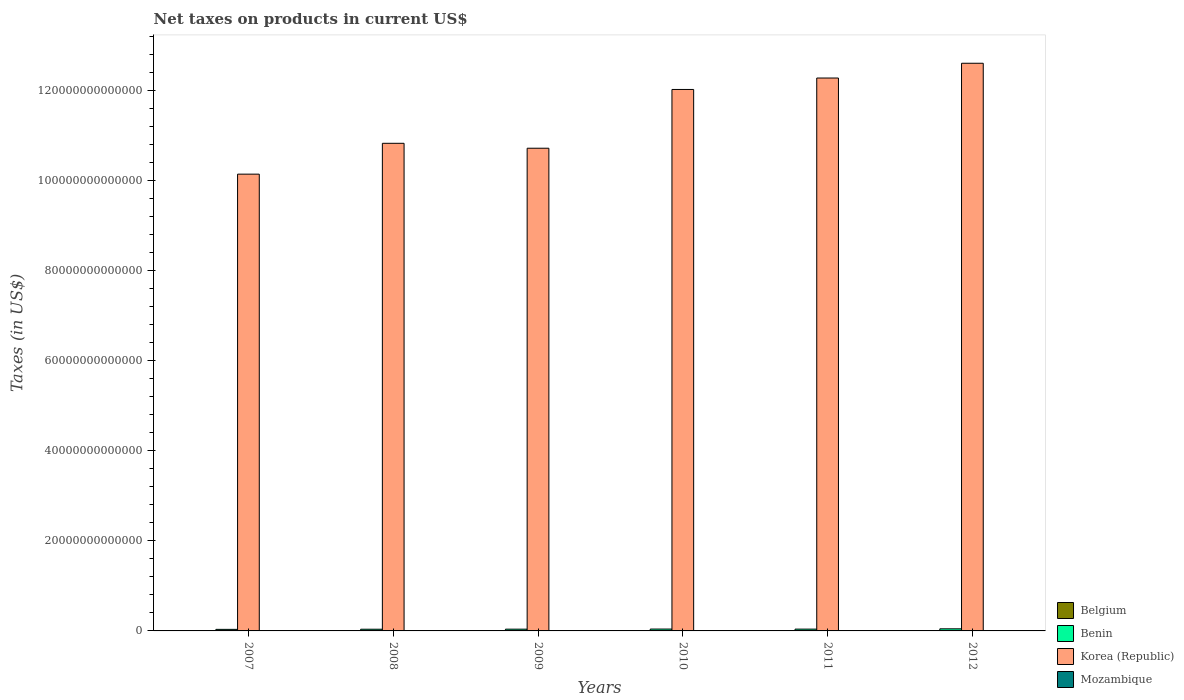How many different coloured bars are there?
Your answer should be very brief. 4. How many bars are there on the 3rd tick from the right?
Your response must be concise. 4. What is the label of the 4th group of bars from the left?
Your answer should be compact. 2010. What is the net taxes on products in Benin in 2012?
Keep it short and to the point. 4.67e+11. Across all years, what is the maximum net taxes on products in Mozambique?
Provide a short and direct response. 3.79e+1. Across all years, what is the minimum net taxes on products in Korea (Republic)?
Make the answer very short. 1.01e+14. In which year was the net taxes on products in Belgium maximum?
Offer a very short reply. 2012. What is the total net taxes on products in Benin in the graph?
Your answer should be compact. 2.40e+12. What is the difference between the net taxes on products in Belgium in 2011 and that in 2012?
Your answer should be very brief. -1.31e+09. What is the difference between the net taxes on products in Benin in 2009 and the net taxes on products in Mozambique in 2012?
Provide a succinct answer. 3.52e+11. What is the average net taxes on products in Korea (Republic) per year?
Make the answer very short. 1.14e+14. In the year 2009, what is the difference between the net taxes on products in Korea (Republic) and net taxes on products in Belgium?
Give a very brief answer. 1.07e+14. What is the ratio of the net taxes on products in Korea (Republic) in 2010 to that in 2011?
Offer a very short reply. 0.98. Is the net taxes on products in Belgium in 2009 less than that in 2011?
Keep it short and to the point. Yes. What is the difference between the highest and the second highest net taxes on products in Belgium?
Make the answer very short. 1.31e+09. What is the difference between the highest and the lowest net taxes on products in Mozambique?
Give a very brief answer. 1.96e+1. In how many years, is the net taxes on products in Mozambique greater than the average net taxes on products in Mozambique taken over all years?
Offer a very short reply. 2. What does the 1st bar from the left in 2007 represents?
Provide a short and direct response. Belgium. Is it the case that in every year, the sum of the net taxes on products in Benin and net taxes on products in Belgium is greater than the net taxes on products in Mozambique?
Provide a succinct answer. Yes. Are all the bars in the graph horizontal?
Give a very brief answer. No. What is the difference between two consecutive major ticks on the Y-axis?
Give a very brief answer. 2.00e+13. Does the graph contain any zero values?
Ensure brevity in your answer.  No. Does the graph contain grids?
Your response must be concise. No. Where does the legend appear in the graph?
Keep it short and to the point. Bottom right. How many legend labels are there?
Provide a succinct answer. 4. What is the title of the graph?
Keep it short and to the point. Net taxes on products in current US$. Does "Bangladesh" appear as one of the legend labels in the graph?
Your answer should be compact. No. What is the label or title of the Y-axis?
Your answer should be very brief. Taxes (in US$). What is the Taxes (in US$) of Belgium in 2007?
Offer a very short reply. 3.68e+1. What is the Taxes (in US$) in Benin in 2007?
Keep it short and to the point. 3.46e+11. What is the Taxes (in US$) of Korea (Republic) in 2007?
Keep it short and to the point. 1.01e+14. What is the Taxes (in US$) of Mozambique in 2007?
Your answer should be compact. 1.82e+1. What is the Taxes (in US$) in Belgium in 2008?
Give a very brief answer. 3.71e+1. What is the Taxes (in US$) in Benin in 2008?
Make the answer very short. 3.77e+11. What is the Taxes (in US$) in Korea (Republic) in 2008?
Give a very brief answer. 1.08e+14. What is the Taxes (in US$) of Mozambique in 2008?
Ensure brevity in your answer.  2.13e+1. What is the Taxes (in US$) in Belgium in 2009?
Offer a very short reply. 3.62e+1. What is the Taxes (in US$) of Benin in 2009?
Provide a succinct answer. 3.90e+11. What is the Taxes (in US$) of Korea (Republic) in 2009?
Offer a terse response. 1.07e+14. What is the Taxes (in US$) of Mozambique in 2009?
Offer a very short reply. 2.17e+1. What is the Taxes (in US$) in Belgium in 2010?
Offer a very short reply. 3.86e+1. What is the Taxes (in US$) in Benin in 2010?
Make the answer very short. 4.14e+11. What is the Taxes (in US$) of Korea (Republic) in 2010?
Your answer should be compact. 1.20e+14. What is the Taxes (in US$) in Mozambique in 2010?
Provide a succinct answer. 2.55e+1. What is the Taxes (in US$) of Belgium in 2011?
Make the answer very short. 3.95e+1. What is the Taxes (in US$) of Benin in 2011?
Keep it short and to the point. 4.02e+11. What is the Taxes (in US$) in Korea (Republic) in 2011?
Make the answer very short. 1.23e+14. What is the Taxes (in US$) in Mozambique in 2011?
Provide a succinct answer. 3.03e+1. What is the Taxes (in US$) in Belgium in 2012?
Your response must be concise. 4.08e+1. What is the Taxes (in US$) in Benin in 2012?
Provide a short and direct response. 4.67e+11. What is the Taxes (in US$) of Korea (Republic) in 2012?
Offer a very short reply. 1.26e+14. What is the Taxes (in US$) of Mozambique in 2012?
Provide a succinct answer. 3.79e+1. Across all years, what is the maximum Taxes (in US$) of Belgium?
Offer a very short reply. 4.08e+1. Across all years, what is the maximum Taxes (in US$) of Benin?
Ensure brevity in your answer.  4.67e+11. Across all years, what is the maximum Taxes (in US$) in Korea (Republic)?
Keep it short and to the point. 1.26e+14. Across all years, what is the maximum Taxes (in US$) in Mozambique?
Provide a short and direct response. 3.79e+1. Across all years, what is the minimum Taxes (in US$) in Belgium?
Give a very brief answer. 3.62e+1. Across all years, what is the minimum Taxes (in US$) of Benin?
Ensure brevity in your answer.  3.46e+11. Across all years, what is the minimum Taxes (in US$) of Korea (Republic)?
Offer a very short reply. 1.01e+14. Across all years, what is the minimum Taxes (in US$) in Mozambique?
Keep it short and to the point. 1.82e+1. What is the total Taxes (in US$) in Belgium in the graph?
Ensure brevity in your answer.  2.29e+11. What is the total Taxes (in US$) of Benin in the graph?
Offer a very short reply. 2.40e+12. What is the total Taxes (in US$) of Korea (Republic) in the graph?
Your answer should be very brief. 6.86e+14. What is the total Taxes (in US$) of Mozambique in the graph?
Provide a short and direct response. 1.55e+11. What is the difference between the Taxes (in US$) in Belgium in 2007 and that in 2008?
Offer a very short reply. -3.04e+08. What is the difference between the Taxes (in US$) in Benin in 2007 and that in 2008?
Keep it short and to the point. -3.13e+1. What is the difference between the Taxes (in US$) of Korea (Republic) in 2007 and that in 2008?
Offer a very short reply. -6.85e+12. What is the difference between the Taxes (in US$) in Mozambique in 2007 and that in 2008?
Provide a succinct answer. -3.04e+09. What is the difference between the Taxes (in US$) of Belgium in 2007 and that in 2009?
Your response must be concise. 5.68e+08. What is the difference between the Taxes (in US$) in Benin in 2007 and that in 2009?
Your answer should be very brief. -4.38e+1. What is the difference between the Taxes (in US$) of Korea (Republic) in 2007 and that in 2009?
Your answer should be very brief. -5.76e+12. What is the difference between the Taxes (in US$) in Mozambique in 2007 and that in 2009?
Offer a very short reply. -3.43e+09. What is the difference between the Taxes (in US$) of Belgium in 2007 and that in 2010?
Offer a very short reply. -1.81e+09. What is the difference between the Taxes (in US$) in Benin in 2007 and that in 2010?
Offer a very short reply. -6.76e+1. What is the difference between the Taxes (in US$) of Korea (Republic) in 2007 and that in 2010?
Ensure brevity in your answer.  -1.88e+13. What is the difference between the Taxes (in US$) in Mozambique in 2007 and that in 2010?
Your response must be concise. -7.21e+09. What is the difference between the Taxes (in US$) in Belgium in 2007 and that in 2011?
Offer a very short reply. -2.71e+09. What is the difference between the Taxes (in US$) of Benin in 2007 and that in 2011?
Offer a very short reply. -5.54e+1. What is the difference between the Taxes (in US$) in Korea (Republic) in 2007 and that in 2011?
Your response must be concise. -2.13e+13. What is the difference between the Taxes (in US$) in Mozambique in 2007 and that in 2011?
Ensure brevity in your answer.  -1.20e+1. What is the difference between the Taxes (in US$) of Belgium in 2007 and that in 2012?
Provide a succinct answer. -4.02e+09. What is the difference between the Taxes (in US$) of Benin in 2007 and that in 2012?
Make the answer very short. -1.21e+11. What is the difference between the Taxes (in US$) of Korea (Republic) in 2007 and that in 2012?
Keep it short and to the point. -2.46e+13. What is the difference between the Taxes (in US$) of Mozambique in 2007 and that in 2012?
Your response must be concise. -1.96e+1. What is the difference between the Taxes (in US$) in Belgium in 2008 and that in 2009?
Provide a short and direct response. 8.72e+08. What is the difference between the Taxes (in US$) in Benin in 2008 and that in 2009?
Provide a short and direct response. -1.25e+1. What is the difference between the Taxes (in US$) in Korea (Republic) in 2008 and that in 2009?
Your response must be concise. 1.09e+12. What is the difference between the Taxes (in US$) in Mozambique in 2008 and that in 2009?
Your answer should be compact. -3.89e+08. What is the difference between the Taxes (in US$) of Belgium in 2008 and that in 2010?
Offer a very short reply. -1.51e+09. What is the difference between the Taxes (in US$) in Benin in 2008 and that in 2010?
Make the answer very short. -3.63e+1. What is the difference between the Taxes (in US$) of Korea (Republic) in 2008 and that in 2010?
Give a very brief answer. -1.19e+13. What is the difference between the Taxes (in US$) in Mozambique in 2008 and that in 2010?
Provide a short and direct response. -4.17e+09. What is the difference between the Taxes (in US$) in Belgium in 2008 and that in 2011?
Your answer should be very brief. -2.40e+09. What is the difference between the Taxes (in US$) of Benin in 2008 and that in 2011?
Provide a short and direct response. -2.41e+1. What is the difference between the Taxes (in US$) of Korea (Republic) in 2008 and that in 2011?
Make the answer very short. -1.45e+13. What is the difference between the Taxes (in US$) in Mozambique in 2008 and that in 2011?
Ensure brevity in your answer.  -8.98e+09. What is the difference between the Taxes (in US$) in Belgium in 2008 and that in 2012?
Provide a succinct answer. -3.72e+09. What is the difference between the Taxes (in US$) in Benin in 2008 and that in 2012?
Provide a short and direct response. -8.93e+1. What is the difference between the Taxes (in US$) of Korea (Republic) in 2008 and that in 2012?
Offer a very short reply. -1.78e+13. What is the difference between the Taxes (in US$) in Mozambique in 2008 and that in 2012?
Your answer should be compact. -1.66e+1. What is the difference between the Taxes (in US$) in Belgium in 2009 and that in 2010?
Provide a short and direct response. -2.38e+09. What is the difference between the Taxes (in US$) in Benin in 2009 and that in 2010?
Offer a very short reply. -2.38e+1. What is the difference between the Taxes (in US$) of Korea (Republic) in 2009 and that in 2010?
Offer a very short reply. -1.30e+13. What is the difference between the Taxes (in US$) in Mozambique in 2009 and that in 2010?
Give a very brief answer. -3.78e+09. What is the difference between the Taxes (in US$) of Belgium in 2009 and that in 2011?
Your answer should be very brief. -3.28e+09. What is the difference between the Taxes (in US$) of Benin in 2009 and that in 2011?
Your answer should be very brief. -1.16e+1. What is the difference between the Taxes (in US$) in Korea (Republic) in 2009 and that in 2011?
Keep it short and to the point. -1.56e+13. What is the difference between the Taxes (in US$) in Mozambique in 2009 and that in 2011?
Provide a short and direct response. -8.59e+09. What is the difference between the Taxes (in US$) of Belgium in 2009 and that in 2012?
Provide a succinct answer. -4.59e+09. What is the difference between the Taxes (in US$) in Benin in 2009 and that in 2012?
Offer a very short reply. -7.68e+1. What is the difference between the Taxes (in US$) of Korea (Republic) in 2009 and that in 2012?
Your answer should be very brief. -1.89e+13. What is the difference between the Taxes (in US$) of Mozambique in 2009 and that in 2012?
Offer a terse response. -1.62e+1. What is the difference between the Taxes (in US$) in Belgium in 2010 and that in 2011?
Offer a very short reply. -8.95e+08. What is the difference between the Taxes (in US$) of Benin in 2010 and that in 2011?
Your response must be concise. 1.22e+1. What is the difference between the Taxes (in US$) of Korea (Republic) in 2010 and that in 2011?
Provide a succinct answer. -2.54e+12. What is the difference between the Taxes (in US$) in Mozambique in 2010 and that in 2011?
Provide a succinct answer. -4.81e+09. What is the difference between the Taxes (in US$) of Belgium in 2010 and that in 2012?
Ensure brevity in your answer.  -2.21e+09. What is the difference between the Taxes (in US$) of Benin in 2010 and that in 2012?
Keep it short and to the point. -5.30e+1. What is the difference between the Taxes (in US$) in Korea (Republic) in 2010 and that in 2012?
Give a very brief answer. -5.82e+12. What is the difference between the Taxes (in US$) of Mozambique in 2010 and that in 2012?
Offer a terse response. -1.24e+1. What is the difference between the Taxes (in US$) in Belgium in 2011 and that in 2012?
Ensure brevity in your answer.  -1.31e+09. What is the difference between the Taxes (in US$) of Benin in 2011 and that in 2012?
Your answer should be very brief. -6.52e+1. What is the difference between the Taxes (in US$) in Korea (Republic) in 2011 and that in 2012?
Make the answer very short. -3.28e+12. What is the difference between the Taxes (in US$) in Mozambique in 2011 and that in 2012?
Offer a very short reply. -7.59e+09. What is the difference between the Taxes (in US$) of Belgium in 2007 and the Taxes (in US$) of Benin in 2008?
Your answer should be compact. -3.41e+11. What is the difference between the Taxes (in US$) of Belgium in 2007 and the Taxes (in US$) of Korea (Republic) in 2008?
Your answer should be very brief. -1.08e+14. What is the difference between the Taxes (in US$) of Belgium in 2007 and the Taxes (in US$) of Mozambique in 2008?
Your answer should be very brief. 1.55e+1. What is the difference between the Taxes (in US$) of Benin in 2007 and the Taxes (in US$) of Korea (Republic) in 2008?
Your answer should be compact. -1.08e+14. What is the difference between the Taxes (in US$) of Benin in 2007 and the Taxes (in US$) of Mozambique in 2008?
Make the answer very short. 3.25e+11. What is the difference between the Taxes (in US$) in Korea (Republic) in 2007 and the Taxes (in US$) in Mozambique in 2008?
Make the answer very short. 1.01e+14. What is the difference between the Taxes (in US$) in Belgium in 2007 and the Taxes (in US$) in Benin in 2009?
Make the answer very short. -3.53e+11. What is the difference between the Taxes (in US$) in Belgium in 2007 and the Taxes (in US$) in Korea (Republic) in 2009?
Offer a very short reply. -1.07e+14. What is the difference between the Taxes (in US$) in Belgium in 2007 and the Taxes (in US$) in Mozambique in 2009?
Keep it short and to the point. 1.51e+1. What is the difference between the Taxes (in US$) in Benin in 2007 and the Taxes (in US$) in Korea (Republic) in 2009?
Offer a terse response. -1.07e+14. What is the difference between the Taxes (in US$) in Benin in 2007 and the Taxes (in US$) in Mozambique in 2009?
Make the answer very short. 3.24e+11. What is the difference between the Taxes (in US$) of Korea (Republic) in 2007 and the Taxes (in US$) of Mozambique in 2009?
Give a very brief answer. 1.01e+14. What is the difference between the Taxes (in US$) in Belgium in 2007 and the Taxes (in US$) in Benin in 2010?
Give a very brief answer. -3.77e+11. What is the difference between the Taxes (in US$) in Belgium in 2007 and the Taxes (in US$) in Korea (Republic) in 2010?
Your response must be concise. -1.20e+14. What is the difference between the Taxes (in US$) in Belgium in 2007 and the Taxes (in US$) in Mozambique in 2010?
Offer a very short reply. 1.13e+1. What is the difference between the Taxes (in US$) in Benin in 2007 and the Taxes (in US$) in Korea (Republic) in 2010?
Your response must be concise. -1.20e+14. What is the difference between the Taxes (in US$) in Benin in 2007 and the Taxes (in US$) in Mozambique in 2010?
Provide a short and direct response. 3.21e+11. What is the difference between the Taxes (in US$) of Korea (Republic) in 2007 and the Taxes (in US$) of Mozambique in 2010?
Provide a succinct answer. 1.01e+14. What is the difference between the Taxes (in US$) of Belgium in 2007 and the Taxes (in US$) of Benin in 2011?
Offer a terse response. -3.65e+11. What is the difference between the Taxes (in US$) of Belgium in 2007 and the Taxes (in US$) of Korea (Republic) in 2011?
Offer a very short reply. -1.23e+14. What is the difference between the Taxes (in US$) of Belgium in 2007 and the Taxes (in US$) of Mozambique in 2011?
Your answer should be compact. 6.49e+09. What is the difference between the Taxes (in US$) of Benin in 2007 and the Taxes (in US$) of Korea (Republic) in 2011?
Make the answer very short. -1.22e+14. What is the difference between the Taxes (in US$) in Benin in 2007 and the Taxes (in US$) in Mozambique in 2011?
Ensure brevity in your answer.  3.16e+11. What is the difference between the Taxes (in US$) in Korea (Republic) in 2007 and the Taxes (in US$) in Mozambique in 2011?
Offer a terse response. 1.01e+14. What is the difference between the Taxes (in US$) of Belgium in 2007 and the Taxes (in US$) of Benin in 2012?
Make the answer very short. -4.30e+11. What is the difference between the Taxes (in US$) in Belgium in 2007 and the Taxes (in US$) in Korea (Republic) in 2012?
Offer a very short reply. -1.26e+14. What is the difference between the Taxes (in US$) of Belgium in 2007 and the Taxes (in US$) of Mozambique in 2012?
Ensure brevity in your answer.  -1.10e+09. What is the difference between the Taxes (in US$) of Benin in 2007 and the Taxes (in US$) of Korea (Republic) in 2012?
Your answer should be very brief. -1.26e+14. What is the difference between the Taxes (in US$) of Benin in 2007 and the Taxes (in US$) of Mozambique in 2012?
Offer a terse response. 3.08e+11. What is the difference between the Taxes (in US$) in Korea (Republic) in 2007 and the Taxes (in US$) in Mozambique in 2012?
Provide a short and direct response. 1.01e+14. What is the difference between the Taxes (in US$) of Belgium in 2008 and the Taxes (in US$) of Benin in 2009?
Keep it short and to the point. -3.53e+11. What is the difference between the Taxes (in US$) of Belgium in 2008 and the Taxes (in US$) of Korea (Republic) in 2009?
Your response must be concise. -1.07e+14. What is the difference between the Taxes (in US$) of Belgium in 2008 and the Taxes (in US$) of Mozambique in 2009?
Give a very brief answer. 1.54e+1. What is the difference between the Taxes (in US$) of Benin in 2008 and the Taxes (in US$) of Korea (Republic) in 2009?
Your answer should be compact. -1.07e+14. What is the difference between the Taxes (in US$) of Benin in 2008 and the Taxes (in US$) of Mozambique in 2009?
Your answer should be very brief. 3.56e+11. What is the difference between the Taxes (in US$) in Korea (Republic) in 2008 and the Taxes (in US$) in Mozambique in 2009?
Ensure brevity in your answer.  1.08e+14. What is the difference between the Taxes (in US$) in Belgium in 2008 and the Taxes (in US$) in Benin in 2010?
Provide a succinct answer. -3.77e+11. What is the difference between the Taxes (in US$) in Belgium in 2008 and the Taxes (in US$) in Korea (Republic) in 2010?
Provide a succinct answer. -1.20e+14. What is the difference between the Taxes (in US$) in Belgium in 2008 and the Taxes (in US$) in Mozambique in 2010?
Your response must be concise. 1.16e+1. What is the difference between the Taxes (in US$) in Benin in 2008 and the Taxes (in US$) in Korea (Republic) in 2010?
Your answer should be very brief. -1.20e+14. What is the difference between the Taxes (in US$) of Benin in 2008 and the Taxes (in US$) of Mozambique in 2010?
Provide a short and direct response. 3.52e+11. What is the difference between the Taxes (in US$) of Korea (Republic) in 2008 and the Taxes (in US$) of Mozambique in 2010?
Offer a terse response. 1.08e+14. What is the difference between the Taxes (in US$) of Belgium in 2008 and the Taxes (in US$) of Benin in 2011?
Your answer should be very brief. -3.64e+11. What is the difference between the Taxes (in US$) of Belgium in 2008 and the Taxes (in US$) of Korea (Republic) in 2011?
Give a very brief answer. -1.23e+14. What is the difference between the Taxes (in US$) in Belgium in 2008 and the Taxes (in US$) in Mozambique in 2011?
Your answer should be very brief. 6.80e+09. What is the difference between the Taxes (in US$) of Benin in 2008 and the Taxes (in US$) of Korea (Republic) in 2011?
Give a very brief answer. -1.22e+14. What is the difference between the Taxes (in US$) in Benin in 2008 and the Taxes (in US$) in Mozambique in 2011?
Your response must be concise. 3.47e+11. What is the difference between the Taxes (in US$) of Korea (Republic) in 2008 and the Taxes (in US$) of Mozambique in 2011?
Your answer should be very brief. 1.08e+14. What is the difference between the Taxes (in US$) of Belgium in 2008 and the Taxes (in US$) of Benin in 2012?
Your answer should be compact. -4.30e+11. What is the difference between the Taxes (in US$) of Belgium in 2008 and the Taxes (in US$) of Korea (Republic) in 2012?
Ensure brevity in your answer.  -1.26e+14. What is the difference between the Taxes (in US$) of Belgium in 2008 and the Taxes (in US$) of Mozambique in 2012?
Make the answer very short. -7.96e+08. What is the difference between the Taxes (in US$) of Benin in 2008 and the Taxes (in US$) of Korea (Republic) in 2012?
Your answer should be compact. -1.26e+14. What is the difference between the Taxes (in US$) of Benin in 2008 and the Taxes (in US$) of Mozambique in 2012?
Offer a very short reply. 3.40e+11. What is the difference between the Taxes (in US$) of Korea (Republic) in 2008 and the Taxes (in US$) of Mozambique in 2012?
Keep it short and to the point. 1.08e+14. What is the difference between the Taxes (in US$) in Belgium in 2009 and the Taxes (in US$) in Benin in 2010?
Make the answer very short. -3.78e+11. What is the difference between the Taxes (in US$) in Belgium in 2009 and the Taxes (in US$) in Korea (Republic) in 2010?
Ensure brevity in your answer.  -1.20e+14. What is the difference between the Taxes (in US$) in Belgium in 2009 and the Taxes (in US$) in Mozambique in 2010?
Offer a terse response. 1.07e+1. What is the difference between the Taxes (in US$) in Benin in 2009 and the Taxes (in US$) in Korea (Republic) in 2010?
Ensure brevity in your answer.  -1.20e+14. What is the difference between the Taxes (in US$) of Benin in 2009 and the Taxes (in US$) of Mozambique in 2010?
Your response must be concise. 3.64e+11. What is the difference between the Taxes (in US$) of Korea (Republic) in 2009 and the Taxes (in US$) of Mozambique in 2010?
Your answer should be very brief. 1.07e+14. What is the difference between the Taxes (in US$) of Belgium in 2009 and the Taxes (in US$) of Benin in 2011?
Your response must be concise. -3.65e+11. What is the difference between the Taxes (in US$) in Belgium in 2009 and the Taxes (in US$) in Korea (Republic) in 2011?
Make the answer very short. -1.23e+14. What is the difference between the Taxes (in US$) in Belgium in 2009 and the Taxes (in US$) in Mozambique in 2011?
Provide a short and direct response. 5.92e+09. What is the difference between the Taxes (in US$) of Benin in 2009 and the Taxes (in US$) of Korea (Republic) in 2011?
Provide a short and direct response. -1.22e+14. What is the difference between the Taxes (in US$) in Benin in 2009 and the Taxes (in US$) in Mozambique in 2011?
Give a very brief answer. 3.60e+11. What is the difference between the Taxes (in US$) in Korea (Republic) in 2009 and the Taxes (in US$) in Mozambique in 2011?
Ensure brevity in your answer.  1.07e+14. What is the difference between the Taxes (in US$) of Belgium in 2009 and the Taxes (in US$) of Benin in 2012?
Your answer should be compact. -4.31e+11. What is the difference between the Taxes (in US$) of Belgium in 2009 and the Taxes (in US$) of Korea (Republic) in 2012?
Make the answer very short. -1.26e+14. What is the difference between the Taxes (in US$) of Belgium in 2009 and the Taxes (in US$) of Mozambique in 2012?
Make the answer very short. -1.67e+09. What is the difference between the Taxes (in US$) in Benin in 2009 and the Taxes (in US$) in Korea (Republic) in 2012?
Your answer should be compact. -1.26e+14. What is the difference between the Taxes (in US$) of Benin in 2009 and the Taxes (in US$) of Mozambique in 2012?
Give a very brief answer. 3.52e+11. What is the difference between the Taxes (in US$) in Korea (Republic) in 2009 and the Taxes (in US$) in Mozambique in 2012?
Provide a short and direct response. 1.07e+14. What is the difference between the Taxes (in US$) in Belgium in 2010 and the Taxes (in US$) in Benin in 2011?
Provide a succinct answer. -3.63e+11. What is the difference between the Taxes (in US$) in Belgium in 2010 and the Taxes (in US$) in Korea (Republic) in 2011?
Your response must be concise. -1.23e+14. What is the difference between the Taxes (in US$) of Belgium in 2010 and the Taxes (in US$) of Mozambique in 2011?
Your response must be concise. 8.31e+09. What is the difference between the Taxes (in US$) of Benin in 2010 and the Taxes (in US$) of Korea (Republic) in 2011?
Make the answer very short. -1.22e+14. What is the difference between the Taxes (in US$) of Benin in 2010 and the Taxes (in US$) of Mozambique in 2011?
Provide a short and direct response. 3.83e+11. What is the difference between the Taxes (in US$) of Korea (Republic) in 2010 and the Taxes (in US$) of Mozambique in 2011?
Offer a terse response. 1.20e+14. What is the difference between the Taxes (in US$) in Belgium in 2010 and the Taxes (in US$) in Benin in 2012?
Offer a very short reply. -4.28e+11. What is the difference between the Taxes (in US$) of Belgium in 2010 and the Taxes (in US$) of Korea (Republic) in 2012?
Your response must be concise. -1.26e+14. What is the difference between the Taxes (in US$) in Belgium in 2010 and the Taxes (in US$) in Mozambique in 2012?
Your answer should be very brief. 7.14e+08. What is the difference between the Taxes (in US$) in Benin in 2010 and the Taxes (in US$) in Korea (Republic) in 2012?
Offer a very short reply. -1.26e+14. What is the difference between the Taxes (in US$) of Benin in 2010 and the Taxes (in US$) of Mozambique in 2012?
Make the answer very short. 3.76e+11. What is the difference between the Taxes (in US$) of Korea (Republic) in 2010 and the Taxes (in US$) of Mozambique in 2012?
Give a very brief answer. 1.20e+14. What is the difference between the Taxes (in US$) in Belgium in 2011 and the Taxes (in US$) in Benin in 2012?
Your answer should be compact. -4.27e+11. What is the difference between the Taxes (in US$) of Belgium in 2011 and the Taxes (in US$) of Korea (Republic) in 2012?
Offer a terse response. -1.26e+14. What is the difference between the Taxes (in US$) of Belgium in 2011 and the Taxes (in US$) of Mozambique in 2012?
Provide a succinct answer. 1.61e+09. What is the difference between the Taxes (in US$) of Benin in 2011 and the Taxes (in US$) of Korea (Republic) in 2012?
Give a very brief answer. -1.26e+14. What is the difference between the Taxes (in US$) of Benin in 2011 and the Taxes (in US$) of Mozambique in 2012?
Keep it short and to the point. 3.64e+11. What is the difference between the Taxes (in US$) of Korea (Republic) in 2011 and the Taxes (in US$) of Mozambique in 2012?
Offer a terse response. 1.23e+14. What is the average Taxes (in US$) in Belgium per year?
Provide a short and direct response. 3.81e+1. What is the average Taxes (in US$) of Benin per year?
Provide a succinct answer. 3.99e+11. What is the average Taxes (in US$) in Korea (Republic) per year?
Keep it short and to the point. 1.14e+14. What is the average Taxes (in US$) in Mozambique per year?
Offer a terse response. 2.58e+1. In the year 2007, what is the difference between the Taxes (in US$) in Belgium and Taxes (in US$) in Benin?
Your answer should be compact. -3.09e+11. In the year 2007, what is the difference between the Taxes (in US$) in Belgium and Taxes (in US$) in Korea (Republic)?
Your answer should be very brief. -1.01e+14. In the year 2007, what is the difference between the Taxes (in US$) of Belgium and Taxes (in US$) of Mozambique?
Provide a short and direct response. 1.85e+1. In the year 2007, what is the difference between the Taxes (in US$) in Benin and Taxes (in US$) in Korea (Republic)?
Offer a terse response. -1.01e+14. In the year 2007, what is the difference between the Taxes (in US$) in Benin and Taxes (in US$) in Mozambique?
Give a very brief answer. 3.28e+11. In the year 2007, what is the difference between the Taxes (in US$) of Korea (Republic) and Taxes (in US$) of Mozambique?
Provide a short and direct response. 1.01e+14. In the year 2008, what is the difference between the Taxes (in US$) in Belgium and Taxes (in US$) in Benin?
Provide a succinct answer. -3.40e+11. In the year 2008, what is the difference between the Taxes (in US$) of Belgium and Taxes (in US$) of Korea (Republic)?
Provide a short and direct response. -1.08e+14. In the year 2008, what is the difference between the Taxes (in US$) in Belgium and Taxes (in US$) in Mozambique?
Offer a very short reply. 1.58e+1. In the year 2008, what is the difference between the Taxes (in US$) in Benin and Taxes (in US$) in Korea (Republic)?
Provide a short and direct response. -1.08e+14. In the year 2008, what is the difference between the Taxes (in US$) in Benin and Taxes (in US$) in Mozambique?
Your answer should be compact. 3.56e+11. In the year 2008, what is the difference between the Taxes (in US$) of Korea (Republic) and Taxes (in US$) of Mozambique?
Ensure brevity in your answer.  1.08e+14. In the year 2009, what is the difference between the Taxes (in US$) of Belgium and Taxes (in US$) of Benin?
Provide a short and direct response. -3.54e+11. In the year 2009, what is the difference between the Taxes (in US$) of Belgium and Taxes (in US$) of Korea (Republic)?
Offer a terse response. -1.07e+14. In the year 2009, what is the difference between the Taxes (in US$) in Belgium and Taxes (in US$) in Mozambique?
Offer a terse response. 1.45e+1. In the year 2009, what is the difference between the Taxes (in US$) in Benin and Taxes (in US$) in Korea (Republic)?
Offer a terse response. -1.07e+14. In the year 2009, what is the difference between the Taxes (in US$) in Benin and Taxes (in US$) in Mozambique?
Make the answer very short. 3.68e+11. In the year 2009, what is the difference between the Taxes (in US$) of Korea (Republic) and Taxes (in US$) of Mozambique?
Provide a short and direct response. 1.07e+14. In the year 2010, what is the difference between the Taxes (in US$) of Belgium and Taxes (in US$) of Benin?
Your answer should be compact. -3.75e+11. In the year 2010, what is the difference between the Taxes (in US$) of Belgium and Taxes (in US$) of Korea (Republic)?
Offer a terse response. -1.20e+14. In the year 2010, what is the difference between the Taxes (in US$) in Belgium and Taxes (in US$) in Mozambique?
Ensure brevity in your answer.  1.31e+1. In the year 2010, what is the difference between the Taxes (in US$) of Benin and Taxes (in US$) of Korea (Republic)?
Offer a very short reply. -1.20e+14. In the year 2010, what is the difference between the Taxes (in US$) in Benin and Taxes (in US$) in Mozambique?
Provide a succinct answer. 3.88e+11. In the year 2010, what is the difference between the Taxes (in US$) of Korea (Republic) and Taxes (in US$) of Mozambique?
Give a very brief answer. 1.20e+14. In the year 2011, what is the difference between the Taxes (in US$) in Belgium and Taxes (in US$) in Benin?
Your answer should be very brief. -3.62e+11. In the year 2011, what is the difference between the Taxes (in US$) of Belgium and Taxes (in US$) of Korea (Republic)?
Offer a terse response. -1.23e+14. In the year 2011, what is the difference between the Taxes (in US$) of Belgium and Taxes (in US$) of Mozambique?
Ensure brevity in your answer.  9.20e+09. In the year 2011, what is the difference between the Taxes (in US$) of Benin and Taxes (in US$) of Korea (Republic)?
Make the answer very short. -1.22e+14. In the year 2011, what is the difference between the Taxes (in US$) of Benin and Taxes (in US$) of Mozambique?
Provide a succinct answer. 3.71e+11. In the year 2011, what is the difference between the Taxes (in US$) of Korea (Republic) and Taxes (in US$) of Mozambique?
Offer a very short reply. 1.23e+14. In the year 2012, what is the difference between the Taxes (in US$) of Belgium and Taxes (in US$) of Benin?
Make the answer very short. -4.26e+11. In the year 2012, what is the difference between the Taxes (in US$) in Belgium and Taxes (in US$) in Korea (Republic)?
Your response must be concise. -1.26e+14. In the year 2012, what is the difference between the Taxes (in US$) in Belgium and Taxes (in US$) in Mozambique?
Your answer should be compact. 2.92e+09. In the year 2012, what is the difference between the Taxes (in US$) of Benin and Taxes (in US$) of Korea (Republic)?
Offer a very short reply. -1.26e+14. In the year 2012, what is the difference between the Taxes (in US$) in Benin and Taxes (in US$) in Mozambique?
Your answer should be compact. 4.29e+11. In the year 2012, what is the difference between the Taxes (in US$) of Korea (Republic) and Taxes (in US$) of Mozambique?
Offer a very short reply. 1.26e+14. What is the ratio of the Taxes (in US$) in Benin in 2007 to that in 2008?
Make the answer very short. 0.92. What is the ratio of the Taxes (in US$) in Korea (Republic) in 2007 to that in 2008?
Provide a short and direct response. 0.94. What is the ratio of the Taxes (in US$) in Mozambique in 2007 to that in 2008?
Provide a short and direct response. 0.86. What is the ratio of the Taxes (in US$) of Belgium in 2007 to that in 2009?
Keep it short and to the point. 1.02. What is the ratio of the Taxes (in US$) of Benin in 2007 to that in 2009?
Your answer should be compact. 0.89. What is the ratio of the Taxes (in US$) of Korea (Republic) in 2007 to that in 2009?
Keep it short and to the point. 0.95. What is the ratio of the Taxes (in US$) of Mozambique in 2007 to that in 2009?
Provide a succinct answer. 0.84. What is the ratio of the Taxes (in US$) in Belgium in 2007 to that in 2010?
Make the answer very short. 0.95. What is the ratio of the Taxes (in US$) of Benin in 2007 to that in 2010?
Offer a terse response. 0.84. What is the ratio of the Taxes (in US$) in Korea (Republic) in 2007 to that in 2010?
Your answer should be very brief. 0.84. What is the ratio of the Taxes (in US$) of Mozambique in 2007 to that in 2010?
Your response must be concise. 0.72. What is the ratio of the Taxes (in US$) in Belgium in 2007 to that in 2011?
Keep it short and to the point. 0.93. What is the ratio of the Taxes (in US$) in Benin in 2007 to that in 2011?
Your answer should be compact. 0.86. What is the ratio of the Taxes (in US$) of Korea (Republic) in 2007 to that in 2011?
Offer a very short reply. 0.83. What is the ratio of the Taxes (in US$) in Mozambique in 2007 to that in 2011?
Your response must be concise. 0.6. What is the ratio of the Taxes (in US$) of Belgium in 2007 to that in 2012?
Ensure brevity in your answer.  0.9. What is the ratio of the Taxes (in US$) of Benin in 2007 to that in 2012?
Offer a terse response. 0.74. What is the ratio of the Taxes (in US$) of Korea (Republic) in 2007 to that in 2012?
Keep it short and to the point. 0.8. What is the ratio of the Taxes (in US$) of Mozambique in 2007 to that in 2012?
Your answer should be compact. 0.48. What is the ratio of the Taxes (in US$) of Belgium in 2008 to that in 2009?
Offer a terse response. 1.02. What is the ratio of the Taxes (in US$) of Benin in 2008 to that in 2009?
Give a very brief answer. 0.97. What is the ratio of the Taxes (in US$) of Korea (Republic) in 2008 to that in 2009?
Your answer should be very brief. 1.01. What is the ratio of the Taxes (in US$) of Mozambique in 2008 to that in 2009?
Make the answer very short. 0.98. What is the ratio of the Taxes (in US$) in Belgium in 2008 to that in 2010?
Your answer should be very brief. 0.96. What is the ratio of the Taxes (in US$) of Benin in 2008 to that in 2010?
Your response must be concise. 0.91. What is the ratio of the Taxes (in US$) of Korea (Republic) in 2008 to that in 2010?
Provide a short and direct response. 0.9. What is the ratio of the Taxes (in US$) in Mozambique in 2008 to that in 2010?
Give a very brief answer. 0.84. What is the ratio of the Taxes (in US$) of Belgium in 2008 to that in 2011?
Make the answer very short. 0.94. What is the ratio of the Taxes (in US$) in Korea (Republic) in 2008 to that in 2011?
Provide a succinct answer. 0.88. What is the ratio of the Taxes (in US$) in Mozambique in 2008 to that in 2011?
Your response must be concise. 0.7. What is the ratio of the Taxes (in US$) of Belgium in 2008 to that in 2012?
Your response must be concise. 0.91. What is the ratio of the Taxes (in US$) in Benin in 2008 to that in 2012?
Give a very brief answer. 0.81. What is the ratio of the Taxes (in US$) in Korea (Republic) in 2008 to that in 2012?
Your answer should be compact. 0.86. What is the ratio of the Taxes (in US$) in Mozambique in 2008 to that in 2012?
Make the answer very short. 0.56. What is the ratio of the Taxes (in US$) in Belgium in 2009 to that in 2010?
Make the answer very short. 0.94. What is the ratio of the Taxes (in US$) in Benin in 2009 to that in 2010?
Your answer should be very brief. 0.94. What is the ratio of the Taxes (in US$) in Korea (Republic) in 2009 to that in 2010?
Your answer should be compact. 0.89. What is the ratio of the Taxes (in US$) in Mozambique in 2009 to that in 2010?
Your answer should be very brief. 0.85. What is the ratio of the Taxes (in US$) in Belgium in 2009 to that in 2011?
Your answer should be compact. 0.92. What is the ratio of the Taxes (in US$) of Benin in 2009 to that in 2011?
Provide a short and direct response. 0.97. What is the ratio of the Taxes (in US$) in Korea (Republic) in 2009 to that in 2011?
Make the answer very short. 0.87. What is the ratio of the Taxes (in US$) in Mozambique in 2009 to that in 2011?
Your response must be concise. 0.72. What is the ratio of the Taxes (in US$) in Belgium in 2009 to that in 2012?
Offer a terse response. 0.89. What is the ratio of the Taxes (in US$) of Benin in 2009 to that in 2012?
Your answer should be very brief. 0.84. What is the ratio of the Taxes (in US$) in Korea (Republic) in 2009 to that in 2012?
Keep it short and to the point. 0.85. What is the ratio of the Taxes (in US$) in Mozambique in 2009 to that in 2012?
Your response must be concise. 0.57. What is the ratio of the Taxes (in US$) of Belgium in 2010 to that in 2011?
Your answer should be very brief. 0.98. What is the ratio of the Taxes (in US$) in Benin in 2010 to that in 2011?
Your response must be concise. 1.03. What is the ratio of the Taxes (in US$) in Korea (Republic) in 2010 to that in 2011?
Ensure brevity in your answer.  0.98. What is the ratio of the Taxes (in US$) of Mozambique in 2010 to that in 2011?
Provide a short and direct response. 0.84. What is the ratio of the Taxes (in US$) in Belgium in 2010 to that in 2012?
Keep it short and to the point. 0.95. What is the ratio of the Taxes (in US$) of Benin in 2010 to that in 2012?
Make the answer very short. 0.89. What is the ratio of the Taxes (in US$) in Korea (Republic) in 2010 to that in 2012?
Make the answer very short. 0.95. What is the ratio of the Taxes (in US$) in Mozambique in 2010 to that in 2012?
Keep it short and to the point. 0.67. What is the ratio of the Taxes (in US$) in Belgium in 2011 to that in 2012?
Make the answer very short. 0.97. What is the ratio of the Taxes (in US$) in Benin in 2011 to that in 2012?
Provide a short and direct response. 0.86. What is the ratio of the Taxes (in US$) in Mozambique in 2011 to that in 2012?
Provide a succinct answer. 0.8. What is the difference between the highest and the second highest Taxes (in US$) of Belgium?
Provide a succinct answer. 1.31e+09. What is the difference between the highest and the second highest Taxes (in US$) of Benin?
Make the answer very short. 5.30e+1. What is the difference between the highest and the second highest Taxes (in US$) in Korea (Republic)?
Keep it short and to the point. 3.28e+12. What is the difference between the highest and the second highest Taxes (in US$) in Mozambique?
Provide a succinct answer. 7.59e+09. What is the difference between the highest and the lowest Taxes (in US$) in Belgium?
Keep it short and to the point. 4.59e+09. What is the difference between the highest and the lowest Taxes (in US$) in Benin?
Offer a terse response. 1.21e+11. What is the difference between the highest and the lowest Taxes (in US$) of Korea (Republic)?
Your answer should be compact. 2.46e+13. What is the difference between the highest and the lowest Taxes (in US$) in Mozambique?
Offer a very short reply. 1.96e+1. 